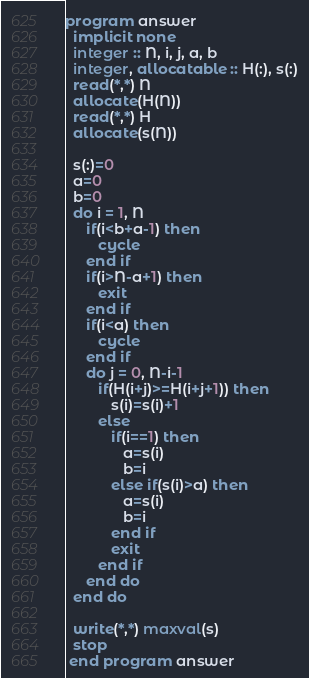<code> <loc_0><loc_0><loc_500><loc_500><_FORTRAN_>program answer
  implicit none
  integer :: N, i, j, a, b
  integer, allocatable :: H(:), s(:)
  read(*,*) N
  allocate(H(N))
  read(*,*) H
  allocate(s(N))

  s(:)=0
  a=0
  b=0
  do i = 1, N
     if(i<b+a-1) then
        cycle
     end if
     if(i>N-a+1) then
        exit
     end if
     if(i<a) then
        cycle
     end if
     do j = 0, N-i-1
        if(H(i+j)>=H(i+j+1)) then
           s(i)=s(i)+1
        else
           if(i==1) then
              a=s(i)
              b=i
           else if(s(i)>a) then
              a=s(i)
              b=i
           end if
           exit
        end if
     end do
  end do

  write(*,*) maxval(s)
  stop
 end program answer</code> 